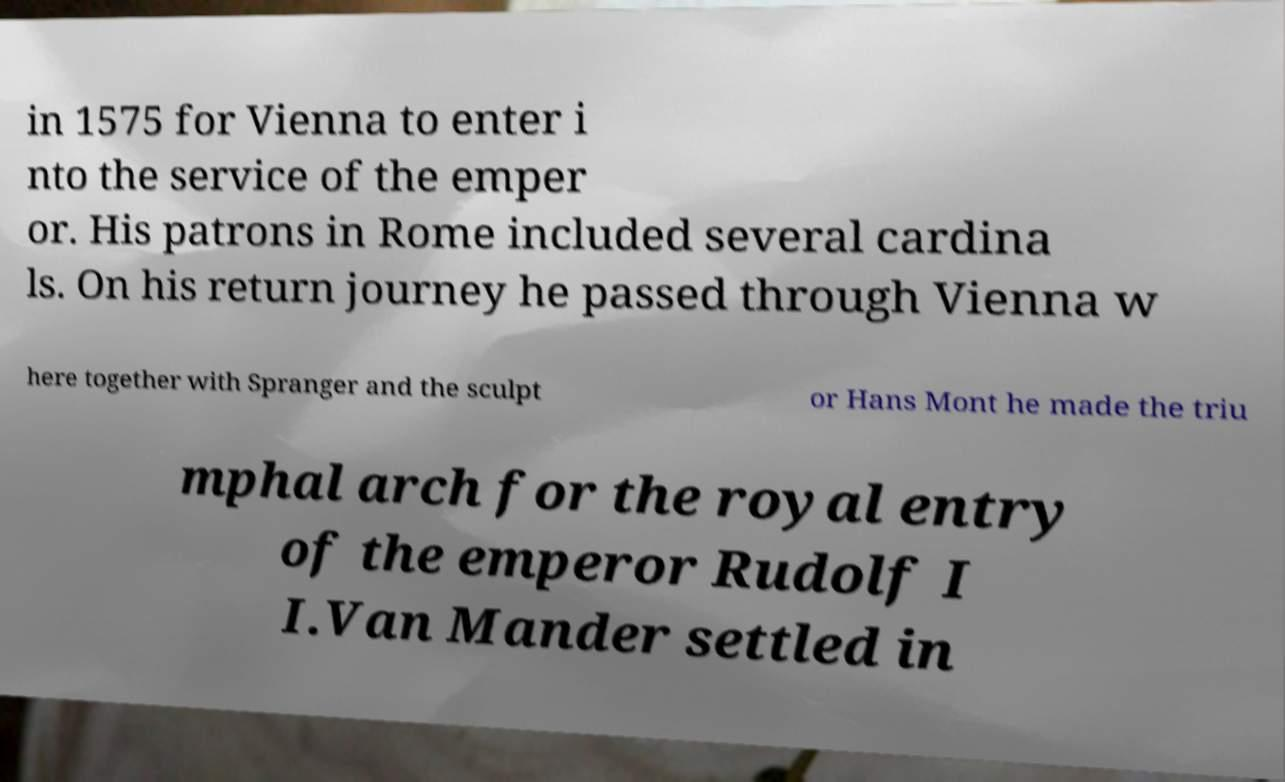Could you extract and type out the text from this image? in 1575 for Vienna to enter i nto the service of the emper or. His patrons in Rome included several cardina ls. On his return journey he passed through Vienna w here together with Spranger and the sculpt or Hans Mont he made the triu mphal arch for the royal entry of the emperor Rudolf I I.Van Mander settled in 